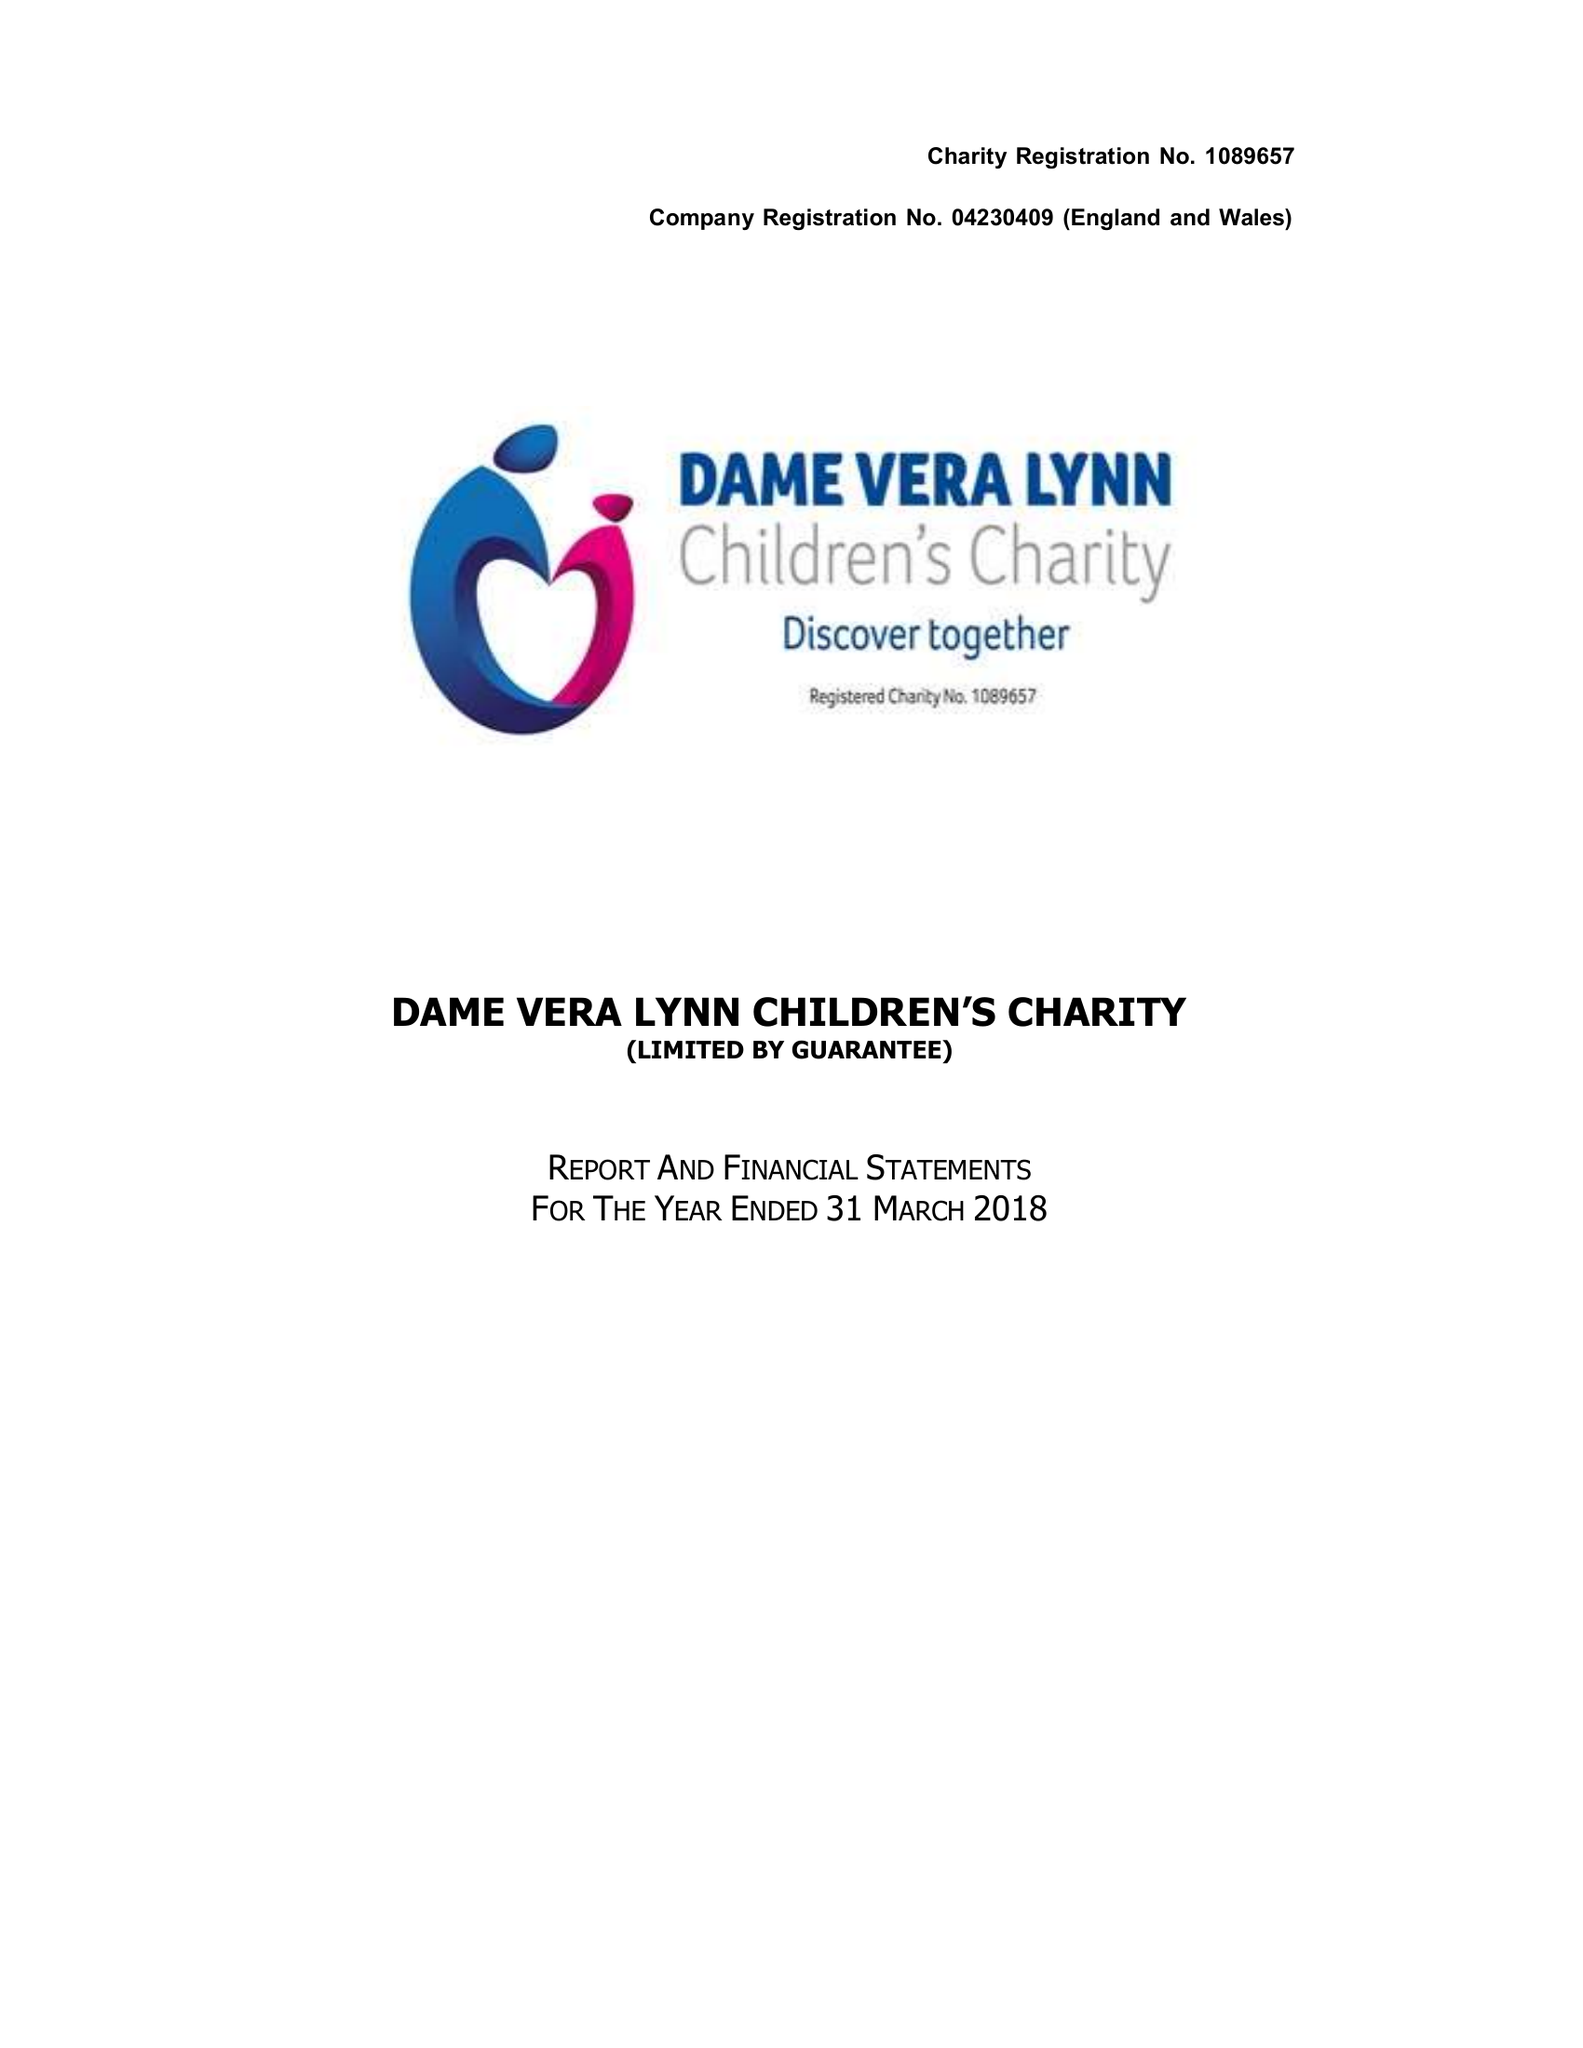What is the value for the income_annually_in_british_pounds?
Answer the question using a single word or phrase. 492708.00 